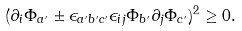<formula> <loc_0><loc_0><loc_500><loc_500>( \partial _ { i } \Phi _ { a ^ { \prime } } \pm \epsilon _ { a ^ { \prime } b ^ { \prime } c ^ { \prime } } \epsilon _ { i j } \Phi _ { b ^ { \prime } } \partial _ { j } \Phi _ { c ^ { \prime } } ) ^ { 2 } \geq 0 .</formula> 